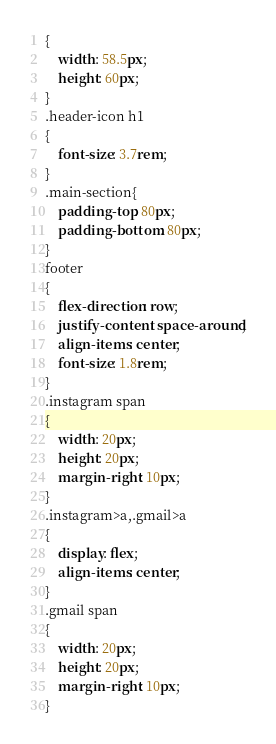Convert code to text. <code><loc_0><loc_0><loc_500><loc_500><_CSS_>{
    width: 58.5px;
    height: 60px;
}
.header-icon h1
{
    font-size: 3.7rem;
}
.main-section{
    padding-top: 80px;
    padding-bottom: 80px;
}
footer
{
    flex-direction: row;
    justify-content: space-around;
    align-items: center;
    font-size: 1.8rem;
}
.instagram span
{
    width: 20px;
    height: 20px;
    margin-right: 10px;
}
.instagram>a,.gmail>a
{
    display: flex;
    align-items: center;
}
.gmail span
{
    width: 20px;
    height: 20px;
    margin-right: 10px;
}</code> 